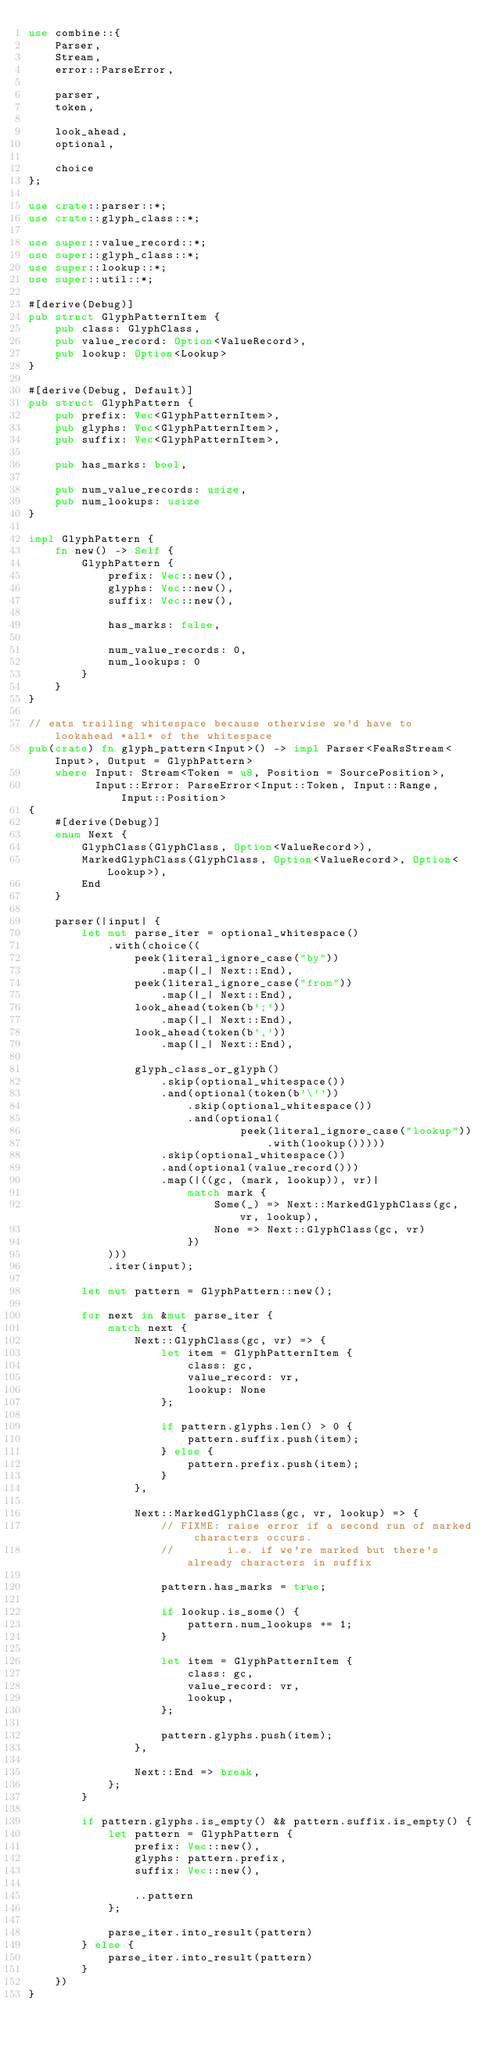Convert code to text. <code><loc_0><loc_0><loc_500><loc_500><_Rust_>use combine::{
    Parser,
    Stream,
    error::ParseError,

    parser,
    token,

    look_ahead,
    optional,

    choice
};

use crate::parser::*;
use crate::glyph_class::*;

use super::value_record::*;
use super::glyph_class::*;
use super::lookup::*;
use super::util::*;

#[derive(Debug)]
pub struct GlyphPatternItem {
    pub class: GlyphClass,
    pub value_record: Option<ValueRecord>,
    pub lookup: Option<Lookup>
}

#[derive(Debug, Default)]
pub struct GlyphPattern {
    pub prefix: Vec<GlyphPatternItem>,
    pub glyphs: Vec<GlyphPatternItem>,
    pub suffix: Vec<GlyphPatternItem>,

    pub has_marks: bool,

    pub num_value_records: usize,
    pub num_lookups: usize
}

impl GlyphPattern {
    fn new() -> Self {
        GlyphPattern {
            prefix: Vec::new(),
            glyphs: Vec::new(),
            suffix: Vec::new(),

            has_marks: false,

            num_value_records: 0,
            num_lookups: 0
        }
    }
}

// eats trailing whitespace because otherwise we'd have to lookahead *all* of the whitespace
pub(crate) fn glyph_pattern<Input>() -> impl Parser<FeaRsStream<Input>, Output = GlyphPattern>
    where Input: Stream<Token = u8, Position = SourcePosition>,
          Input::Error: ParseError<Input::Token, Input::Range, Input::Position>
{
    #[derive(Debug)]
    enum Next {
        GlyphClass(GlyphClass, Option<ValueRecord>),
        MarkedGlyphClass(GlyphClass, Option<ValueRecord>, Option<Lookup>),
        End
    }

    parser(|input| {
        let mut parse_iter = optional_whitespace()
            .with(choice((
                peek(literal_ignore_case("by"))
                    .map(|_| Next::End),
                peek(literal_ignore_case("from"))
                    .map(|_| Next::End),
                look_ahead(token(b';'))
                    .map(|_| Next::End),
                look_ahead(token(b','))
                    .map(|_| Next::End),

                glyph_class_or_glyph()
                    .skip(optional_whitespace())
                    .and(optional(token(b'\''))
                        .skip(optional_whitespace())
                        .and(optional(
                                peek(literal_ignore_case("lookup"))
                                    .with(lookup()))))
                    .skip(optional_whitespace())
                    .and(optional(value_record()))
                    .map(|((gc, (mark, lookup)), vr)|
                        match mark {
                            Some(_) => Next::MarkedGlyphClass(gc, vr, lookup),
                            None => Next::GlyphClass(gc, vr)
                        })
            )))
            .iter(input);

        let mut pattern = GlyphPattern::new();

        for next in &mut parse_iter {
            match next {
                Next::GlyphClass(gc, vr) => {
                    let item = GlyphPatternItem {
                        class: gc,
                        value_record: vr,
                        lookup: None
                    };

                    if pattern.glyphs.len() > 0 {
                        pattern.suffix.push(item);
                    } else {
                        pattern.prefix.push(item);
                    }
                },

                Next::MarkedGlyphClass(gc, vr, lookup) => {
                    // FIXME: raise error if a second run of marked characters occurs.
                    //        i.e. if we're marked but there's already characters in suffix

                    pattern.has_marks = true;

                    if lookup.is_some() {
                        pattern.num_lookups += 1;
                    }

                    let item = GlyphPatternItem {
                        class: gc,
                        value_record: vr,
                        lookup,
                    };

                    pattern.glyphs.push(item);
                },

                Next::End => break,
            };
        }

        if pattern.glyphs.is_empty() && pattern.suffix.is_empty() {
            let pattern = GlyphPattern {
                prefix: Vec::new(),
                glyphs: pattern.prefix,
                suffix: Vec::new(),

                ..pattern
            };

            parse_iter.into_result(pattern)
        } else {
            parse_iter.into_result(pattern)
        }
    })
}
</code> 